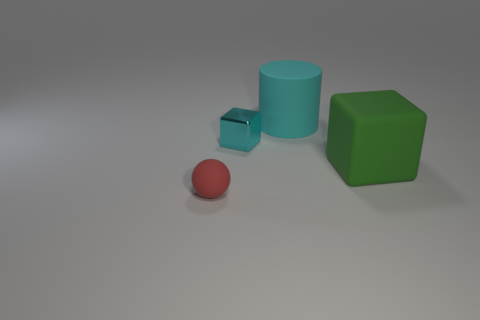Are there any other things that are the same material as the tiny cyan block?
Make the answer very short. No. What is the size of the rubber cylinder that is the same color as the small metal object?
Keep it short and to the point. Large. Are there any rubber objects that have the same color as the small metallic object?
Ensure brevity in your answer.  Yes. What color is the matte cylinder that is the same size as the matte block?
Give a very brief answer. Cyan. Do the metal thing and the small red object have the same shape?
Provide a short and direct response. No. There is a tiny object that is behind the big matte cube; what is its material?
Provide a succinct answer. Metal. What is the color of the big rubber cylinder?
Provide a succinct answer. Cyan. There is a rubber thing on the left side of the tiny metal block; does it have the same size as the rubber thing on the right side of the big cyan object?
Ensure brevity in your answer.  No. How big is the object that is both on the left side of the large cyan rubber cylinder and behind the tiny matte sphere?
Your answer should be compact. Small. What is the color of the big rubber thing that is the same shape as the tiny cyan metallic thing?
Keep it short and to the point. Green. 